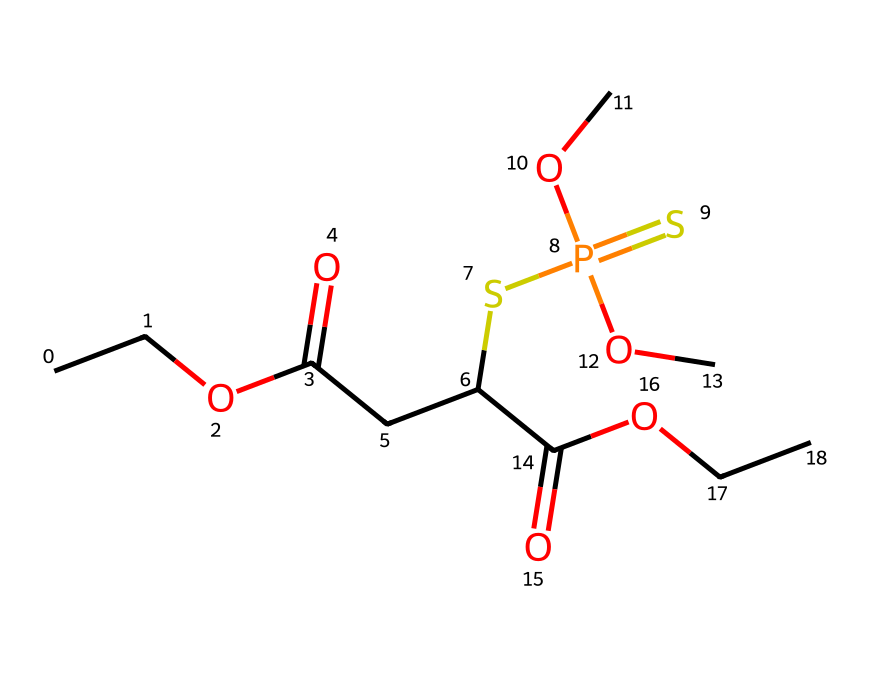What is the total number of carbon atoms in this chemical? To determine the total number of carbon atoms, we examine the carbon-containing parts of the SMILES notation. There are 9 'C' atoms represented across various segments of the structure.
Answer: 9 How many oxygen atoms are present in this compound? By counting the 'O' atoms in the SMILES representation, we can identify the total. The compound has 6 oxygen atoms indicated in different functional groups.
Answer: 6 What functional group is indicated by the 'C(=O)' notation? The 'C(=O)' portion displays a carbon atom double-bonded to an oxygen atom, which signifies a carbonyl functional group, specifically indicating it is a part of a carboxylic acid or ester.
Answer: carbonyl Is this compound considered an organophosphate? The presence of phosphorus (P) in conjunction with alkoxy groups and the general structure aligns with the characteristics of organophosphate compounds, confirming its classification as such.
Answer: yes How many sulfur atoms are in this chemical? Looking at the SMILES, we can identify one 'S' atom present within the structure, linked to the phosphorus atom, which is characteristic of some organophosphorus compounds.
Answer: 1 What type of phosphorus compound does this structure represent? Given the structure's features—specifically the P(=S)—it represents a thiophosphate, which includes phosphorus bonded with sulfur and carbon-based groups.
Answer: thiophosphate What is the relationship between the phosphorus and sulfur in this compound? The phosphorus atom is bonded to the sulfur atom through a double bond (as indicated by P(=S)), suggesting that this is a key relationship that highlights the presence of a thiophosphate moiety.
Answer: double bond 